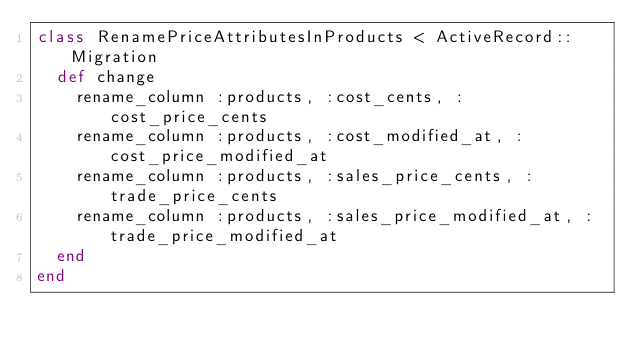<code> <loc_0><loc_0><loc_500><loc_500><_Ruby_>class RenamePriceAttributesInProducts < ActiveRecord::Migration
  def change
    rename_column :products, :cost_cents, :cost_price_cents
    rename_column :products, :cost_modified_at, :cost_price_modified_at
    rename_column :products, :sales_price_cents, :trade_price_cents
    rename_column :products, :sales_price_modified_at, :trade_price_modified_at
  end
end
</code> 